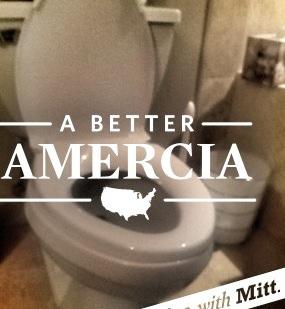Is the trashcan empty?
Keep it brief. Yes. What is the color of the toilet bowl?
Be succinct. White. Is the seat up or down?
Keep it brief. Up. 